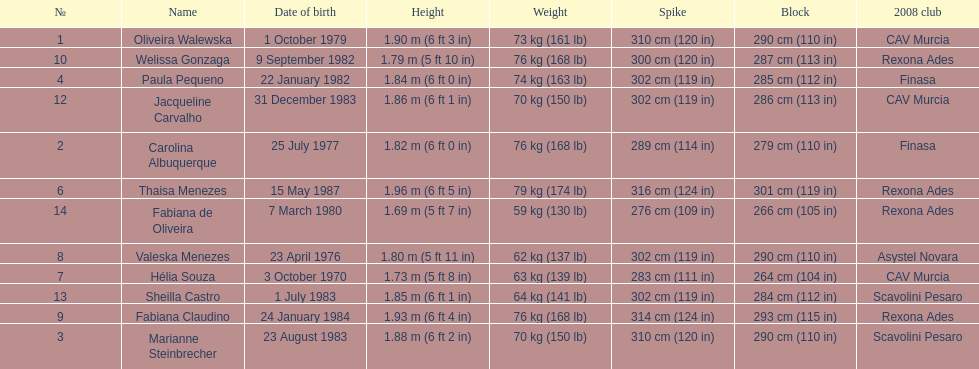Could you parse the entire table as a dict? {'header': ['№', 'Name', 'Date of birth', 'Height', 'Weight', 'Spike', 'Block', '2008 club'], 'rows': [['1', 'Oliveira Walewska', '1 October 1979', '1.90\xa0m (6\xa0ft 3\xa0in)', '73\xa0kg (161\xa0lb)', '310\xa0cm (120\xa0in)', '290\xa0cm (110\xa0in)', 'CAV Murcia'], ['10', 'Welissa Gonzaga', '9 September 1982', '1.79\xa0m (5\xa0ft 10\xa0in)', '76\xa0kg (168\xa0lb)', '300\xa0cm (120\xa0in)', '287\xa0cm (113\xa0in)', 'Rexona Ades'], ['4', 'Paula Pequeno', '22 January 1982', '1.84\xa0m (6\xa0ft 0\xa0in)', '74\xa0kg (163\xa0lb)', '302\xa0cm (119\xa0in)', '285\xa0cm (112\xa0in)', 'Finasa'], ['12', 'Jacqueline Carvalho', '31 December 1983', '1.86\xa0m (6\xa0ft 1\xa0in)', '70\xa0kg (150\xa0lb)', '302\xa0cm (119\xa0in)', '286\xa0cm (113\xa0in)', 'CAV Murcia'], ['2', 'Carolina Albuquerque', '25 July 1977', '1.82\xa0m (6\xa0ft 0\xa0in)', '76\xa0kg (168\xa0lb)', '289\xa0cm (114\xa0in)', '279\xa0cm (110\xa0in)', 'Finasa'], ['6', 'Thaisa Menezes', '15 May 1987', '1.96\xa0m (6\xa0ft 5\xa0in)', '79\xa0kg (174\xa0lb)', '316\xa0cm (124\xa0in)', '301\xa0cm (119\xa0in)', 'Rexona Ades'], ['14', 'Fabiana de Oliveira', '7 March 1980', '1.69\xa0m (5\xa0ft 7\xa0in)', '59\xa0kg (130\xa0lb)', '276\xa0cm (109\xa0in)', '266\xa0cm (105\xa0in)', 'Rexona Ades'], ['8', 'Valeska Menezes', '23 April 1976', '1.80\xa0m (5\xa0ft 11\xa0in)', '62\xa0kg (137\xa0lb)', '302\xa0cm (119\xa0in)', '290\xa0cm (110\xa0in)', 'Asystel Novara'], ['7', 'Hélia Souza', '3 October 1970', '1.73\xa0m (5\xa0ft 8\xa0in)', '63\xa0kg (139\xa0lb)', '283\xa0cm (111\xa0in)', '264\xa0cm (104\xa0in)', 'CAV Murcia'], ['13', 'Sheilla Castro', '1 July 1983', '1.85\xa0m (6\xa0ft 1\xa0in)', '64\xa0kg (141\xa0lb)', '302\xa0cm (119\xa0in)', '284\xa0cm (112\xa0in)', 'Scavolini Pesaro'], ['9', 'Fabiana Claudino', '24 January 1984', '1.93\xa0m (6\xa0ft 4\xa0in)', '76\xa0kg (168\xa0lb)', '314\xa0cm (124\xa0in)', '293\xa0cm (115\xa0in)', 'Rexona Ades'], ['3', 'Marianne Steinbrecher', '23 August 1983', '1.88\xa0m (6\xa0ft 2\xa0in)', '70\xa0kg (150\xa0lb)', '310\xa0cm (120\xa0in)', '290\xa0cm (110\xa0in)', 'Scavolini Pesaro']]} Whose weight is the heaviest among the following: fabiana de oliveira, helia souza, or sheilla castro? Sheilla Castro. 